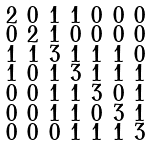Convert formula to latex. <formula><loc_0><loc_0><loc_500><loc_500>\begin{smallmatrix} 2 & 0 & 1 & 1 & 0 & 0 & 0 \\ 0 & 2 & 1 & 0 & 0 & 0 & 0 \\ 1 & 1 & 3 & 1 & 1 & 1 & 0 \\ 1 & 0 & 1 & 3 & 1 & 1 & 1 \\ 0 & 0 & 1 & 1 & 3 & 0 & 1 \\ 0 & 0 & 1 & 1 & 0 & 3 & 1 \\ 0 & 0 & 0 & 1 & 1 & 1 & 3 \end{smallmatrix}</formula> 